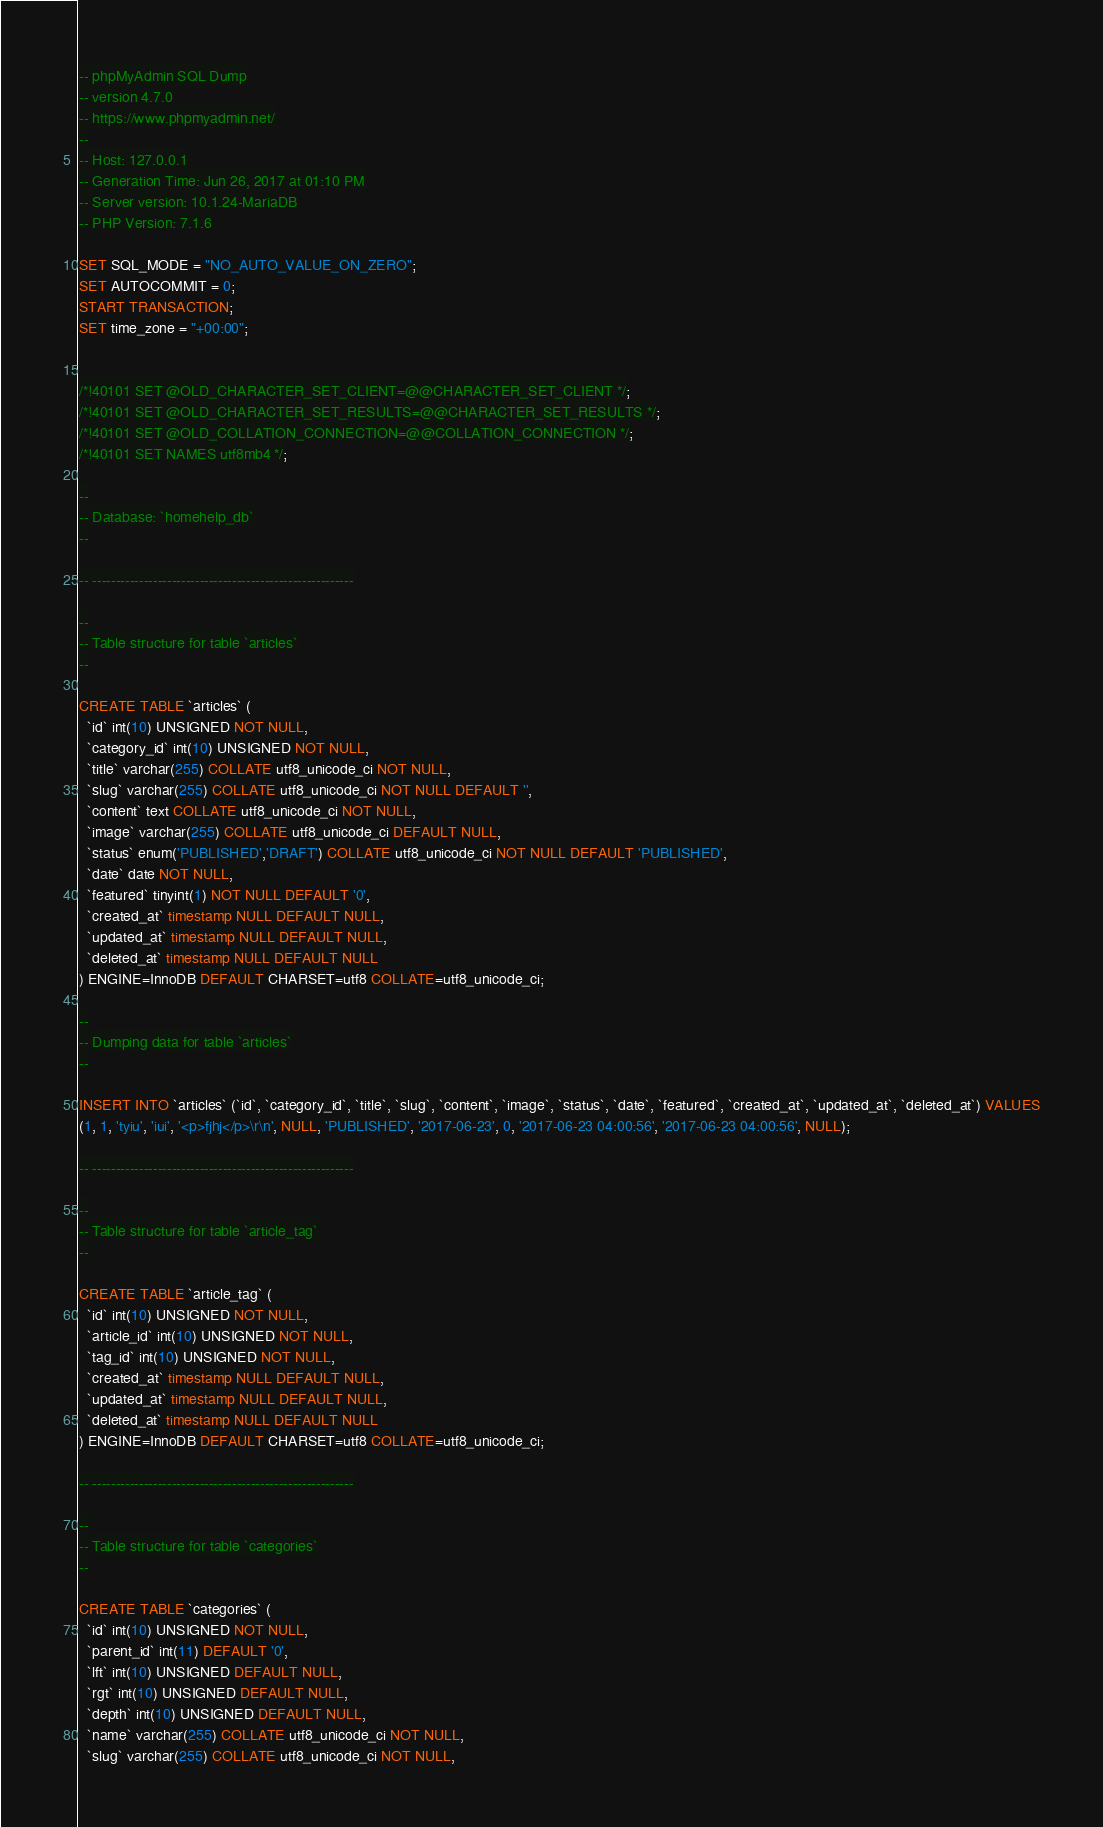<code> <loc_0><loc_0><loc_500><loc_500><_SQL_>-- phpMyAdmin SQL Dump
-- version 4.7.0
-- https://www.phpmyadmin.net/
--
-- Host: 127.0.0.1
-- Generation Time: Jun 26, 2017 at 01:10 PM
-- Server version: 10.1.24-MariaDB
-- PHP Version: 7.1.6

SET SQL_MODE = "NO_AUTO_VALUE_ON_ZERO";
SET AUTOCOMMIT = 0;
START TRANSACTION;
SET time_zone = "+00:00";


/*!40101 SET @OLD_CHARACTER_SET_CLIENT=@@CHARACTER_SET_CLIENT */;
/*!40101 SET @OLD_CHARACTER_SET_RESULTS=@@CHARACTER_SET_RESULTS */;
/*!40101 SET @OLD_COLLATION_CONNECTION=@@COLLATION_CONNECTION */;
/*!40101 SET NAMES utf8mb4 */;

--
-- Database: `homehelp_db`
--

-- --------------------------------------------------------

--
-- Table structure for table `articles`
--

CREATE TABLE `articles` (
  `id` int(10) UNSIGNED NOT NULL,
  `category_id` int(10) UNSIGNED NOT NULL,
  `title` varchar(255) COLLATE utf8_unicode_ci NOT NULL,
  `slug` varchar(255) COLLATE utf8_unicode_ci NOT NULL DEFAULT '',
  `content` text COLLATE utf8_unicode_ci NOT NULL,
  `image` varchar(255) COLLATE utf8_unicode_ci DEFAULT NULL,
  `status` enum('PUBLISHED','DRAFT') COLLATE utf8_unicode_ci NOT NULL DEFAULT 'PUBLISHED',
  `date` date NOT NULL,
  `featured` tinyint(1) NOT NULL DEFAULT '0',
  `created_at` timestamp NULL DEFAULT NULL,
  `updated_at` timestamp NULL DEFAULT NULL,
  `deleted_at` timestamp NULL DEFAULT NULL
) ENGINE=InnoDB DEFAULT CHARSET=utf8 COLLATE=utf8_unicode_ci;

--
-- Dumping data for table `articles`
--

INSERT INTO `articles` (`id`, `category_id`, `title`, `slug`, `content`, `image`, `status`, `date`, `featured`, `created_at`, `updated_at`, `deleted_at`) VALUES
(1, 1, 'tyiu', 'iui', '<p>fjhj</p>\r\n', NULL, 'PUBLISHED', '2017-06-23', 0, '2017-06-23 04:00:56', '2017-06-23 04:00:56', NULL);

-- --------------------------------------------------------

--
-- Table structure for table `article_tag`
--

CREATE TABLE `article_tag` (
  `id` int(10) UNSIGNED NOT NULL,
  `article_id` int(10) UNSIGNED NOT NULL,
  `tag_id` int(10) UNSIGNED NOT NULL,
  `created_at` timestamp NULL DEFAULT NULL,
  `updated_at` timestamp NULL DEFAULT NULL,
  `deleted_at` timestamp NULL DEFAULT NULL
) ENGINE=InnoDB DEFAULT CHARSET=utf8 COLLATE=utf8_unicode_ci;

-- --------------------------------------------------------

--
-- Table structure for table `categories`
--

CREATE TABLE `categories` (
  `id` int(10) UNSIGNED NOT NULL,
  `parent_id` int(11) DEFAULT '0',
  `lft` int(10) UNSIGNED DEFAULT NULL,
  `rgt` int(10) UNSIGNED DEFAULT NULL,
  `depth` int(10) UNSIGNED DEFAULT NULL,
  `name` varchar(255) COLLATE utf8_unicode_ci NOT NULL,
  `slug` varchar(255) COLLATE utf8_unicode_ci NOT NULL,</code> 